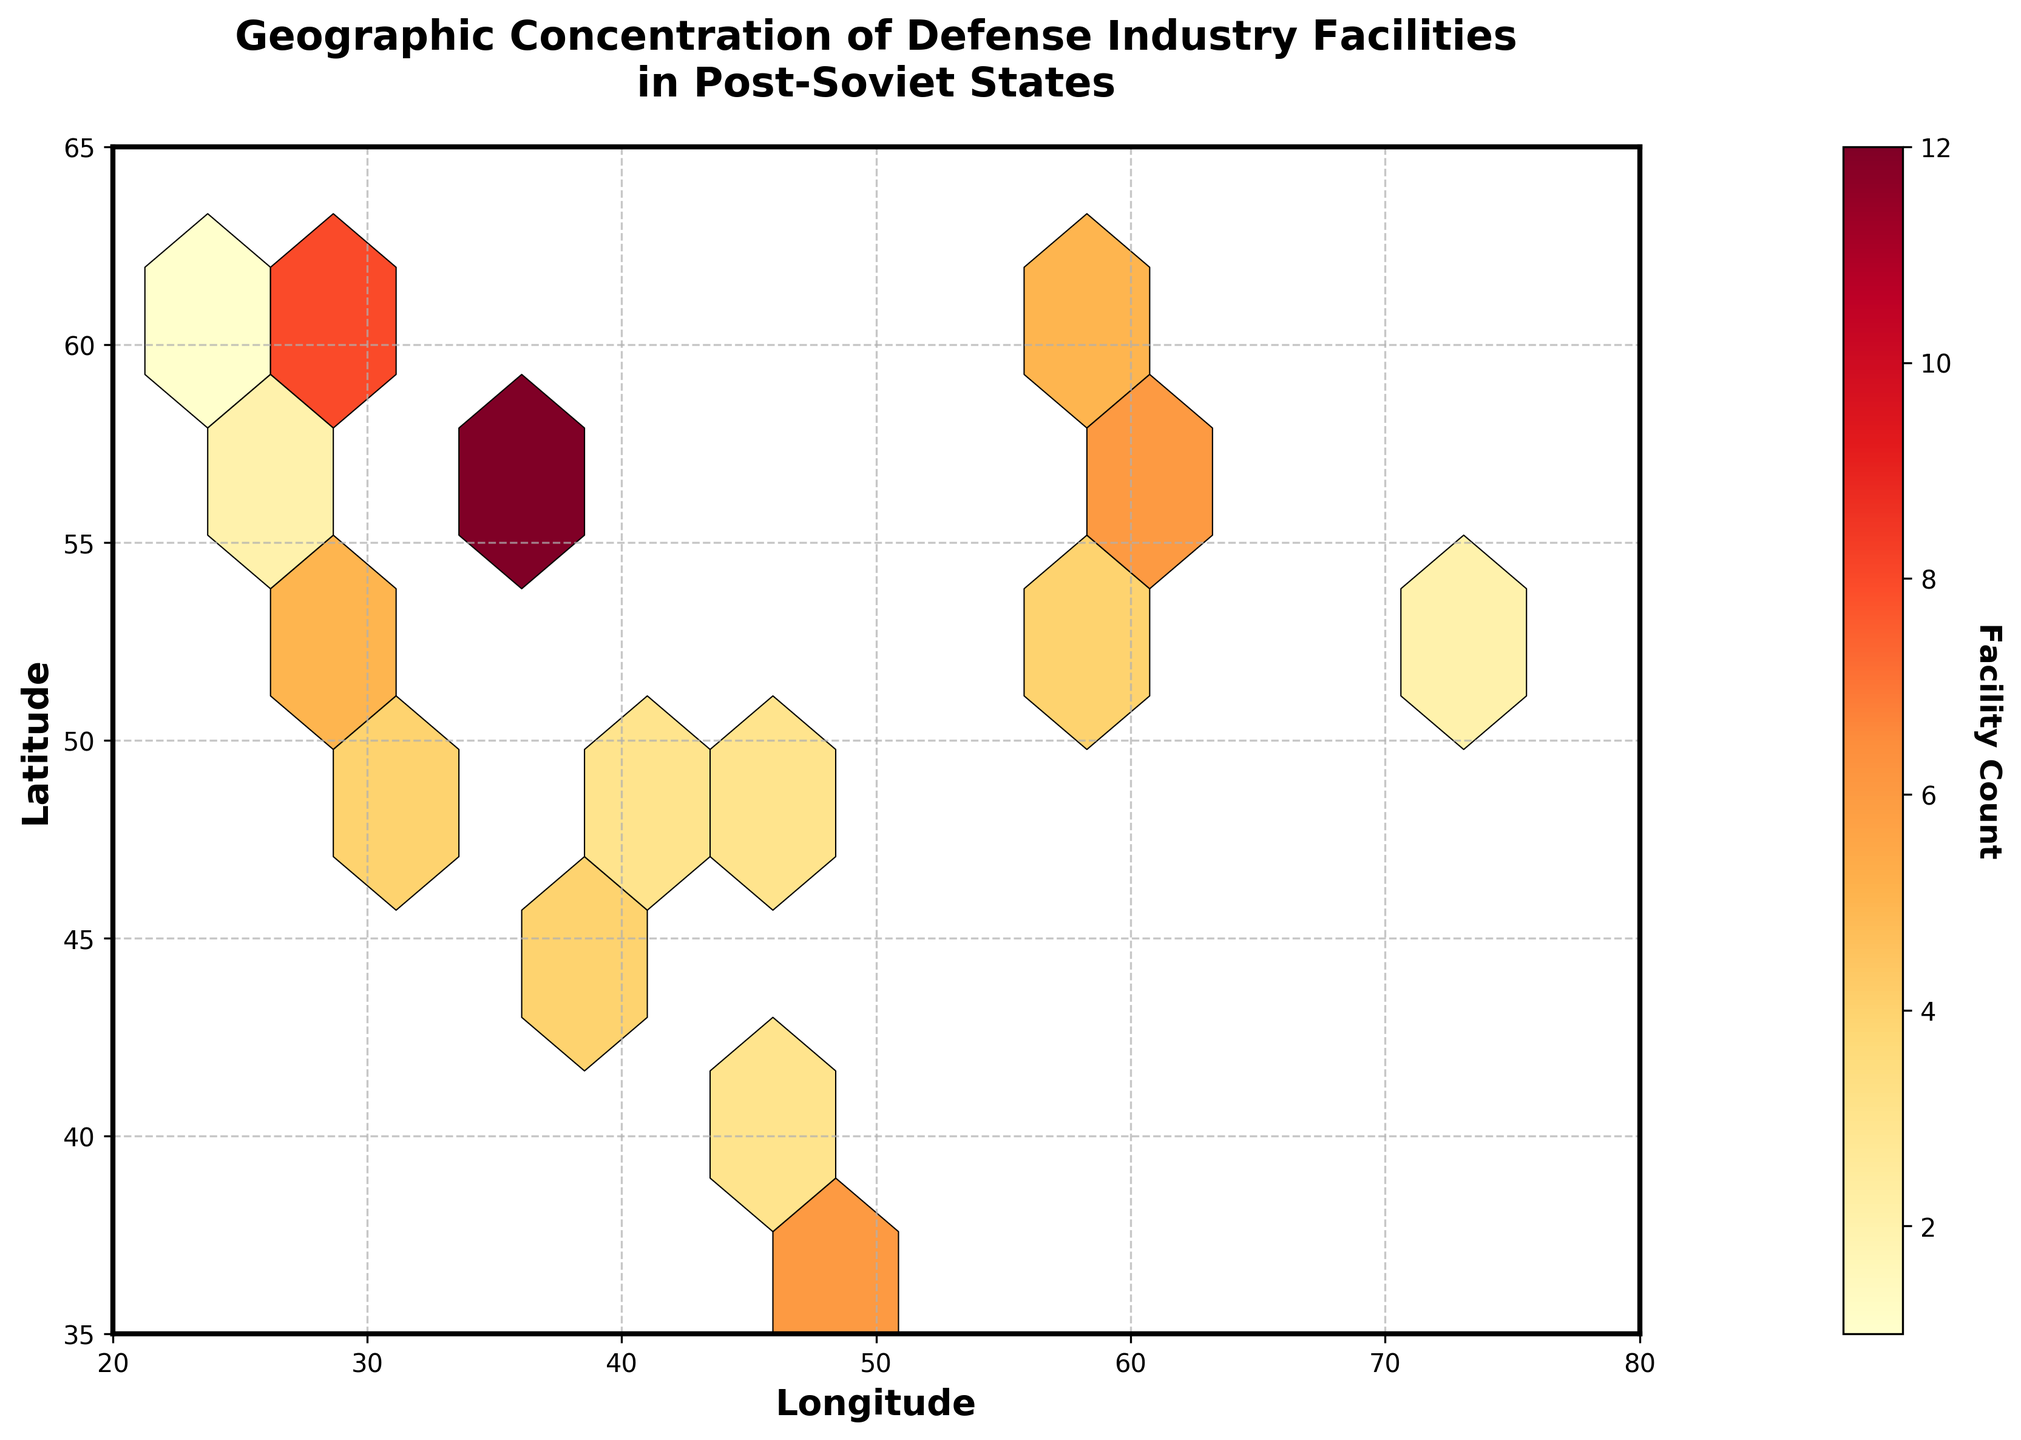what is the title of the plot? The title is the text at the top of the plot, "Geographic Concentration of Defense Industry Facilities in Post-Soviet States." This title gives a clear idea about what the plot represents.
Answer: Geographic Concentration of Defense Industry Facilities in Post-Soviet States How many colors are used in the hex cells to represent the facility count? By observing the plot, one can see varying colors representing different facility counts. The color map ranges from light yellow to dark red, indicating different densities.
Answer: Multiple colors (ranging from yellow to red) What's the latitude range shown in the plot? The latitude range can be understood by looking at the y-axis. The values range from approximately 35 to 65, as indicated by the axis labels.
Answer: 35 to 65 Which areas have the highest concentration of defense facilities? Areas with the highest concentration are represented by the darkest red cells. By examining the plot, one can identify these zones.
Answer: Around Moscow (longitude 37.6173, latitude 55.7558) Which city has the second highest number of defense facilities? By checking the facility counts, Moscow (12) is the highest, followed by another city with 8 facilities. The corresponding longitude and latitude point to St. Petersburg.
Answer: St. Petersburg (longitude 30.3141, latitude 59.9386) Are there more defense facilities concentrated in the eastern or western part of the plot? Comparing the two halves of the plot along the longitudinal median, count the facility densities. More facilities are concentrated in the western part.
Answer: Western part How does the geographic distribution correlate with major cities in post-Soviet states? Examining the plot and comparing it with the map of post-Soviet states, major cities like Moscow and St. Petersburg have higher facility counts.
Answer: Major cities have higher concentrations What color represents a low facility count of 2 or 3? Observing the color bar, the lighter yellow and light orange colors typically represent lower facility counts ranging from 2 to 3.
Answer: Light yellow to light orange Are there any regions with no defense facilities? By scanning the plot, cells with no color or boundaries indicate the absence of defense facilities in those regions.
Answer: Yes, several regions 